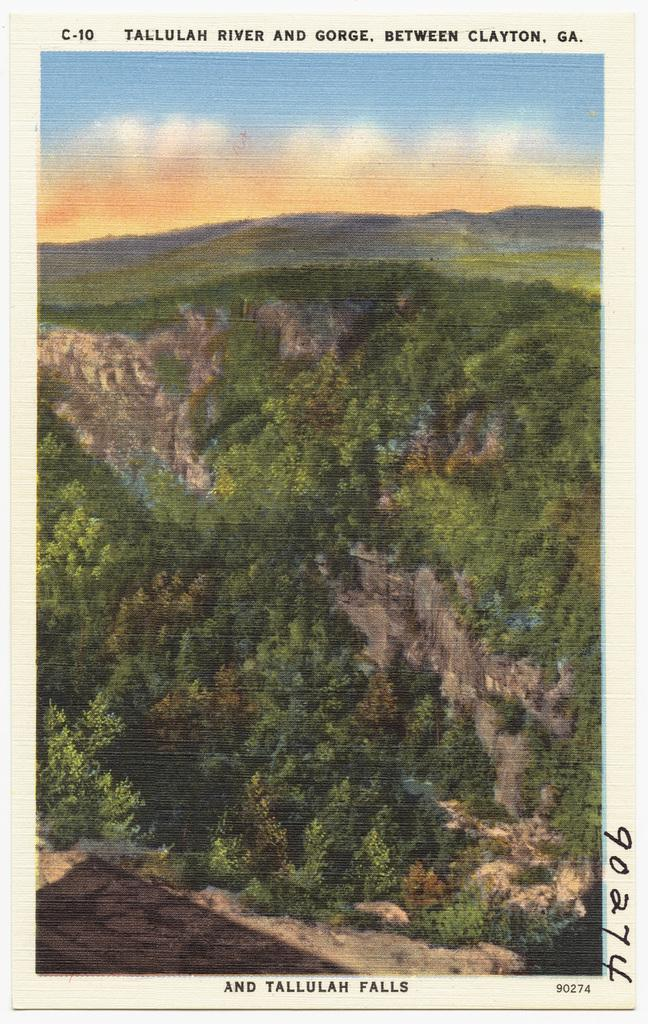What is the main subject of the image? There is a photo in the image. What type of natural elements can be seen in the image? There are trees in the image. What is visible in the background of the image? There is a sky visible in the image. What type of chin can be seen on the trees in the image? There are no chins present in the image, as it features a photo, trees, and a sky. 